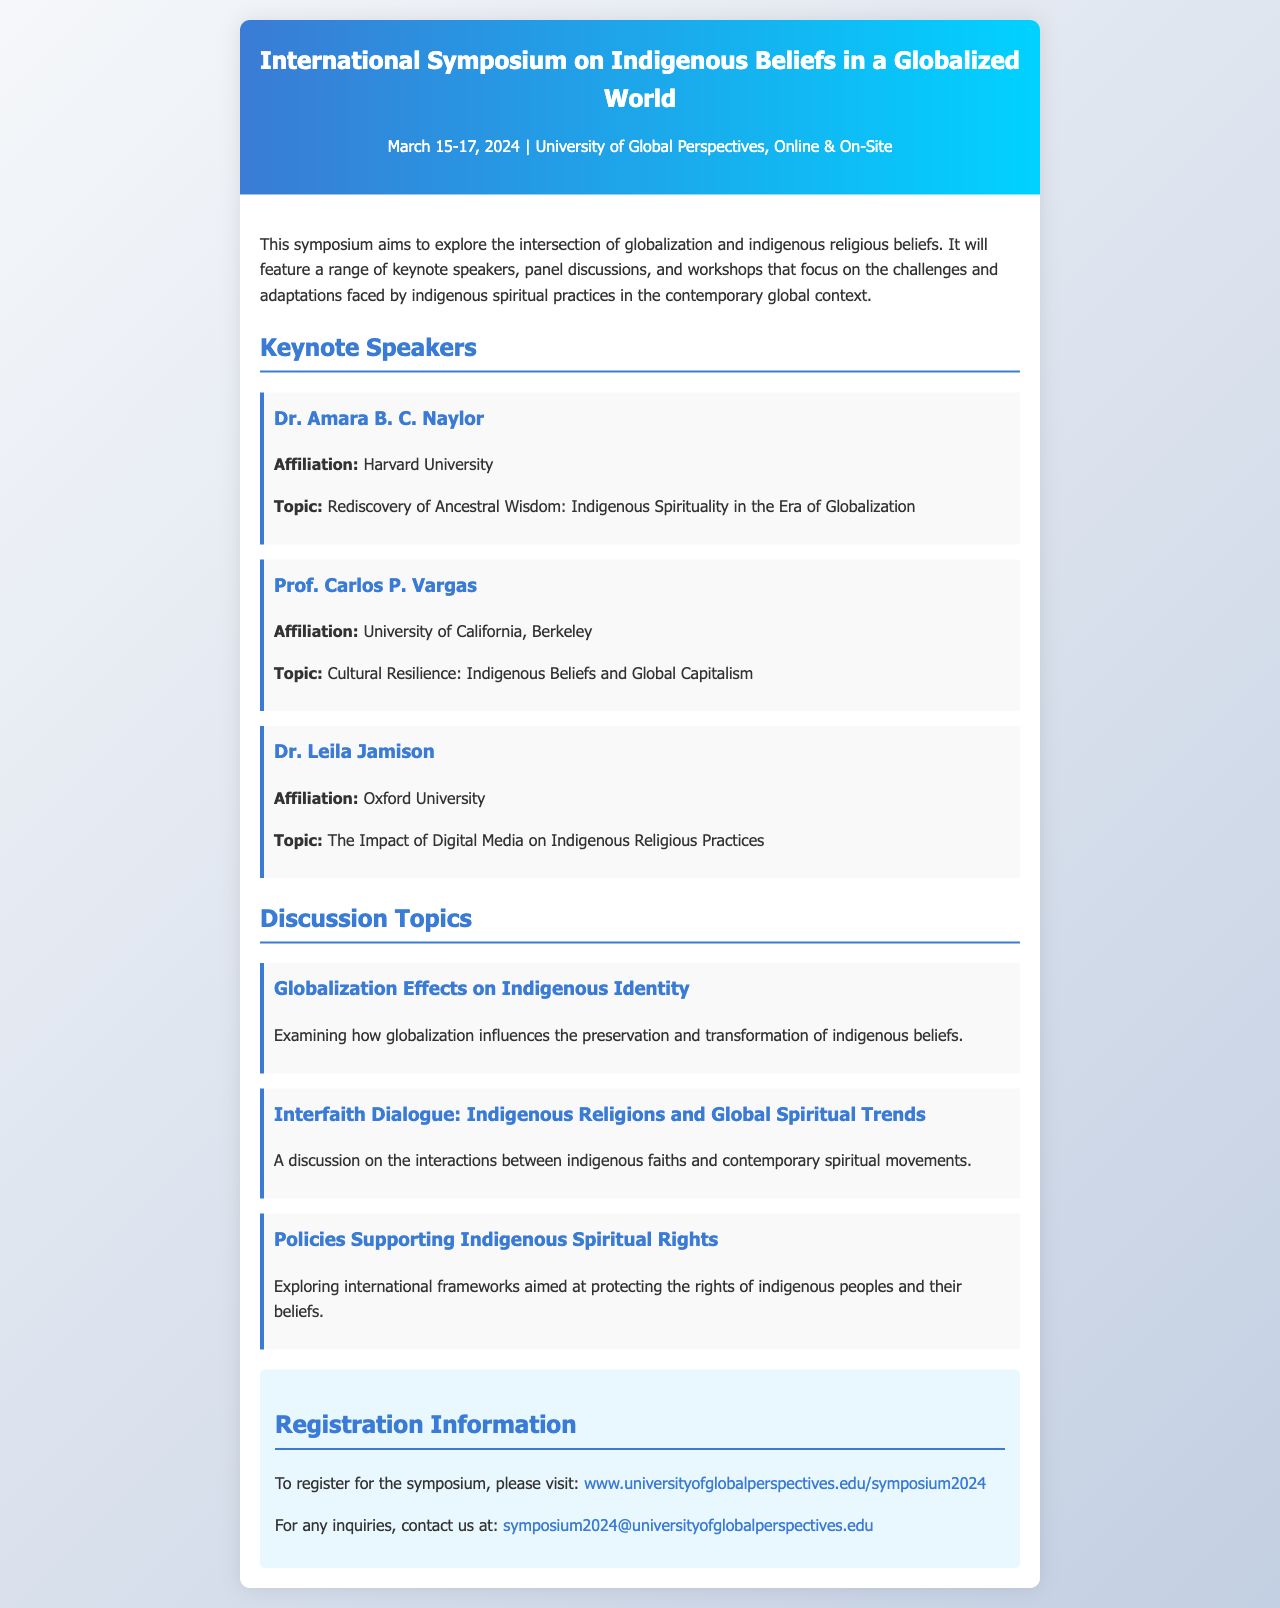What are the dates of the symposium? The document states that the symposium will be held from March 15-17, 2024.
Answer: March 15-17, 2024 Who is the keynote speaker from Harvard University? The document provides the name of the speaker affiliated with Harvard University, which is Dr. Amara B. C. Naylor.
Answer: Dr. Amara B. C. Naylor What is the main focus of the symposium? The document explains that the symposium aims to explore the intersection of globalization and indigenous religious beliefs.
Answer: Intersection of globalization and indigenous religious beliefs What topic will Prof. Carlos P. Vargas discuss? The document lists the topic for Prof. Carlos P. Vargas as "Cultural Resilience: Indigenous Beliefs and Global Capitalism."
Answer: Cultural Resilience: Indigenous Beliefs and Global Capitalism How many discussion topics are mentioned in the document? The document lists three distinct discussion topics that will be discussed during the symposium.
Answer: Three What framework is being explored in the discussion topic titled "Policies Supporting Indigenous Spiritual Rights"? This topic explores international frameworks aimed at protecting the rights of indigenous peoples and their beliefs.
Answer: International frameworks What is the contact email for inquiries regarding the symposium? The document provides the contact email for inquiries as symposium2024@universityofglobalperspectives.edu.
Answer: symposium2024@universityofglobalperspectives.edu Where is the symposium taking place? The document states that the symposium will take place at the University of Global Perspectives, both online and on-site.
Answer: University of Global Perspectives, Online & On-Site 